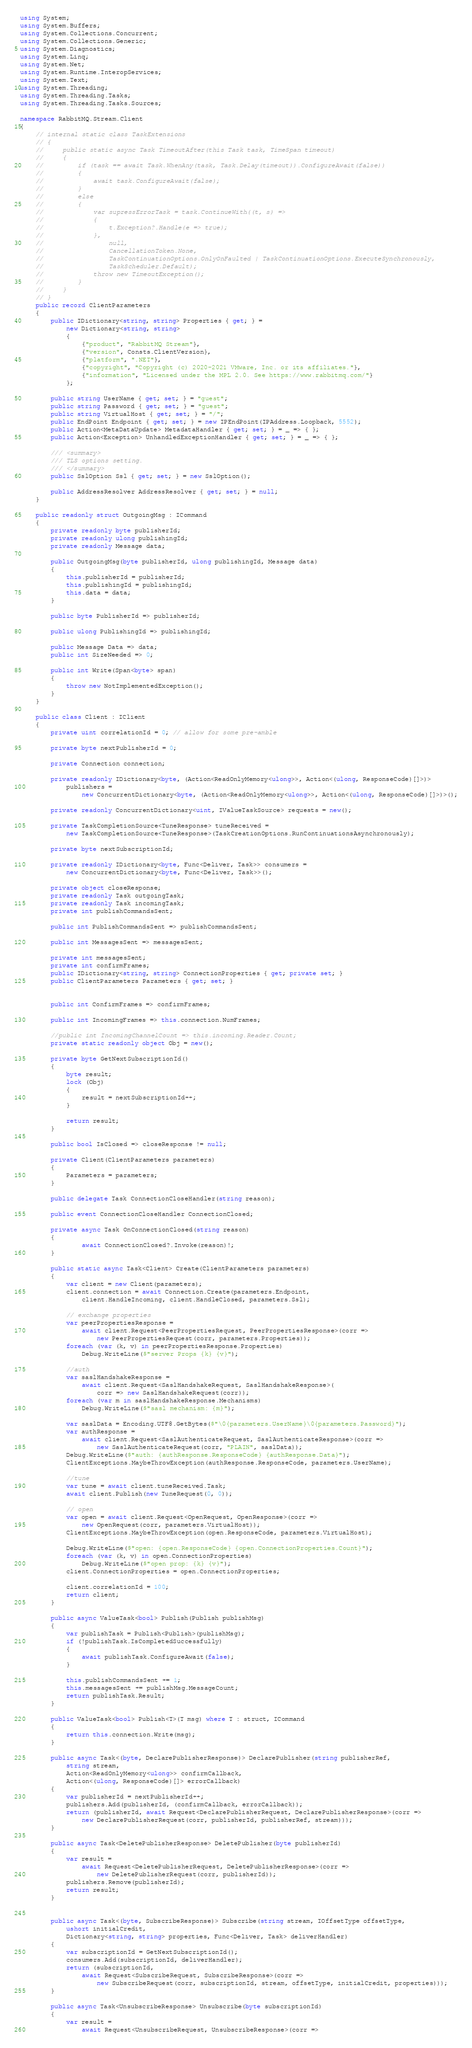Convert code to text. <code><loc_0><loc_0><loc_500><loc_500><_C#_>using System;
using System.Buffers;
using System.Collections.Concurrent;
using System.Collections.Generic;
using System.Diagnostics;
using System.Linq;
using System.Net;
using System.Runtime.InteropServices;
using System.Text;
using System.Threading;
using System.Threading.Tasks;
using System.Threading.Tasks.Sources;

namespace RabbitMQ.Stream.Client
{
    // internal static class TaskExtensions
    // {
    //     public static async Task TimeoutAfter(this Task task, TimeSpan timeout)
    //     {
    //         if (task == await Task.WhenAny(task, Task.Delay(timeout)).ConfigureAwait(false))
    //         {
    //             await task.ConfigureAwait(false);
    //         }
    //         else
    //         {
    //             var supressErrorTask = task.ContinueWith((t, s) =>
    //             {
    //                 t.Exception?.Handle(e => true);
    //             },
    //                 null,
    //                 CancellationToken.None,
    //                 TaskContinuationOptions.OnlyOnFaulted | TaskContinuationOptions.ExecuteSynchronously,
    //                 TaskScheduler.Default);
    //             throw new TimeoutException();
    //         }
    //     }
    // }
    public record ClientParameters
    {
        public IDictionary<string, string> Properties { get; } =
            new Dictionary<string, string>
            {
                {"product", "RabbitMQ Stream"},
                {"version", Consts.ClientVersion},
                {"platform", ".NET"},
                {"copyright", "Copyright (c) 2020-2021 VMware, Inc. or its affiliates."},
                {"information", "Licensed under the MPL 2.0. See https://www.rabbitmq.com/"}
            };

        public string UserName { get; set; } = "guest";
        public string Password { get; set; } = "guest";
        public string VirtualHost { get; set; } = "/";
        public EndPoint Endpoint { get; set; } = new IPEndPoint(IPAddress.Loopback, 5552);
        public Action<MetaDataUpdate> MetadataHandler { get; set; } = _ => { };
        public Action<Exception> UnhandledExceptionHandler { get; set; } = _ => { };

        /// <summary>
        /// TLS options setting.
        /// </summary>
        public SslOption Ssl { get; set; } = new SslOption();

        public AddressResolver AddressResolver { get; set; } = null;
    }

    public readonly struct OutgoingMsg : ICommand
    {
        private readonly byte publisherId;
        private readonly ulong publishingId;
        private readonly Message data;

        public OutgoingMsg(byte publisherId, ulong publishingId, Message data)
        {
            this.publisherId = publisherId;
            this.publishingId = publishingId;
            this.data = data;
        }

        public byte PublisherId => publisherId;

        public ulong PublishingId => publishingId;

        public Message Data => data;
        public int SizeNeeded => 0;

        public int Write(Span<byte> span)
        {
            throw new NotImplementedException();
        }
    }

    public class Client : IClient
    {
        private uint correlationId = 0; // allow for some pre-amble

        private byte nextPublisherId = 0;
      
        private Connection connection;

        private readonly IDictionary<byte, (Action<ReadOnlyMemory<ulong>>, Action<(ulong, ResponseCode)[]>)>
            publishers =
                new ConcurrentDictionary<byte, (Action<ReadOnlyMemory<ulong>>, Action<(ulong, ResponseCode)[]>)>();

        private readonly ConcurrentDictionary<uint, IValueTaskSource> requests = new();

        private TaskCompletionSource<TuneResponse> tuneReceived =
            new TaskCompletionSource<TuneResponse>(TaskCreationOptions.RunContinuationsAsynchronously);

        private byte nextSubscriptionId;

        private readonly IDictionary<byte, Func<Deliver, Task>> consumers =
            new ConcurrentDictionary<byte, Func<Deliver, Task>>();

        private object closeResponse;
        private readonly Task outgoingTask;
        private readonly Task incomingTask;
        private int publishCommandsSent;

        public int PublishCommandsSent => publishCommandsSent;

        public int MessagesSent => messagesSent;

        private int messagesSent;
        private int confirmFrames;
        public IDictionary<string, string> ConnectionProperties { get; private set; }
        public ClientParameters Parameters { get; set; }


        public int ConfirmFrames => confirmFrames;

        public int IncomingFrames => this.connection.NumFrames;

        //public int IncomingChannelCount => this.incoming.Reader.Count;
        private static readonly object Obj = new();

        private byte GetNextSubscriptionId()
        {
            byte result;
            lock (Obj)
            {
                result = nextSubscriptionId++;
            }

            return result;
        }

        public bool IsClosed => closeResponse != null;

        private Client(ClientParameters parameters)
        {
            Parameters = parameters;
        }

        public delegate Task ConnectionCloseHandler(string reason);

        public event ConnectionCloseHandler ConnectionClosed;

        private async Task OnConnectionClosed(string reason)
        {
                await ConnectionClosed?.Invoke(reason)!;
        }
        
        public static async Task<Client> Create(ClientParameters parameters)
        {
            var client = new Client(parameters);
            client.connection = await Connection.Create(parameters.Endpoint,
                client.HandleIncoming, client.HandleClosed, parameters.Ssl);

            // exchange properties
            var peerPropertiesResponse =
                await client.Request<PeerPropertiesRequest, PeerPropertiesResponse>(corr =>
                    new PeerPropertiesRequest(corr, parameters.Properties));
            foreach (var (k, v) in peerPropertiesResponse.Properties)
                Debug.WriteLine($"server Props {k} {v}");

            //auth
            var saslHandshakeResponse =
                await client.Request<SaslHandshakeRequest, SaslHandshakeResponse>(
                    corr => new SaslHandshakeRequest(corr));
            foreach (var m in saslHandshakeResponse.Mechanisms)
                Debug.WriteLine($"sasl mechanism: {m}");

            var saslData = Encoding.UTF8.GetBytes($"\0{parameters.UserName}\0{parameters.Password}");
            var authResponse =
                await client.Request<SaslAuthenticateRequest, SaslAuthenticateResponse>(corr =>
                    new SaslAuthenticateRequest(corr, "PLAIN", saslData));
            Debug.WriteLine($"auth: {authResponse.ResponseCode} {authResponse.Data}");
            ClientExceptions.MaybeThrowException(authResponse.ResponseCode, parameters.UserName);

            //tune
            var tune = await client.tuneReceived.Task;
            await client.Publish(new TuneRequest(0, 0));

            // open 
            var open = await client.Request<OpenRequest, OpenResponse>(corr =>
                new OpenRequest(corr, parameters.VirtualHost));
            ClientExceptions.MaybeThrowException(open.ResponseCode, parameters.VirtualHost);

            Debug.WriteLine($"open: {open.ResponseCode} {open.ConnectionProperties.Count}");
            foreach (var (k, v) in open.ConnectionProperties)
                Debug.WriteLine($"open prop: {k} {v}");
            client.ConnectionProperties = open.ConnectionProperties;

            client.correlationId = 100;
            return client;
        }

        public async ValueTask<bool> Publish(Publish publishMsg)
        {
            var publishTask = Publish<Publish>(publishMsg);
            if (!publishTask.IsCompletedSuccessfully)
            {
                await publishTask.ConfigureAwait(false);
            }

            this.publishCommandsSent += 1;
            this.messagesSent += publishMsg.MessageCount;
            return publishTask.Result;
        }

        public ValueTask<bool> Publish<T>(T msg) where T : struct, ICommand
        {
            return this.connection.Write(msg);
        }

        public async Task<(byte, DeclarePublisherResponse)> DeclarePublisher(string publisherRef,
            string stream,
            Action<ReadOnlyMemory<ulong>> confirmCallback,
            Action<(ulong, ResponseCode)[]> errorCallback)
        {
            var publisherId = nextPublisherId++;
            publishers.Add(publisherId, (confirmCallback, errorCallback));
            return (publisherId, await Request<DeclarePublisherRequest, DeclarePublisherResponse>(corr =>
                new DeclarePublisherRequest(corr, publisherId, publisherRef, stream)));
        }

        public async Task<DeletePublisherResponse> DeletePublisher(byte publisherId)
        {
            var result =
                await Request<DeletePublisherRequest, DeletePublisherResponse>(corr =>
                    new DeletePublisherRequest(corr, publisherId));
            publishers.Remove(publisherId);
            return result;
        }


        public async Task<(byte, SubscribeResponse)> Subscribe(string stream, IOffsetType offsetType,
            ushort initialCredit,
            Dictionary<string, string> properties, Func<Deliver, Task> deliverHandler)
        {
            var subscriptionId = GetNextSubscriptionId();
            consumers.Add(subscriptionId, deliverHandler);
            return (subscriptionId,
                await Request<SubscribeRequest, SubscribeResponse>(corr =>
                    new SubscribeRequest(corr, subscriptionId, stream, offsetType, initialCredit, properties)));
        }

        public async Task<UnsubscribeResponse> Unsubscribe(byte subscriptionId)
        {
            var result =
                await Request<UnsubscribeRequest, UnsubscribeResponse>(corr =></code> 